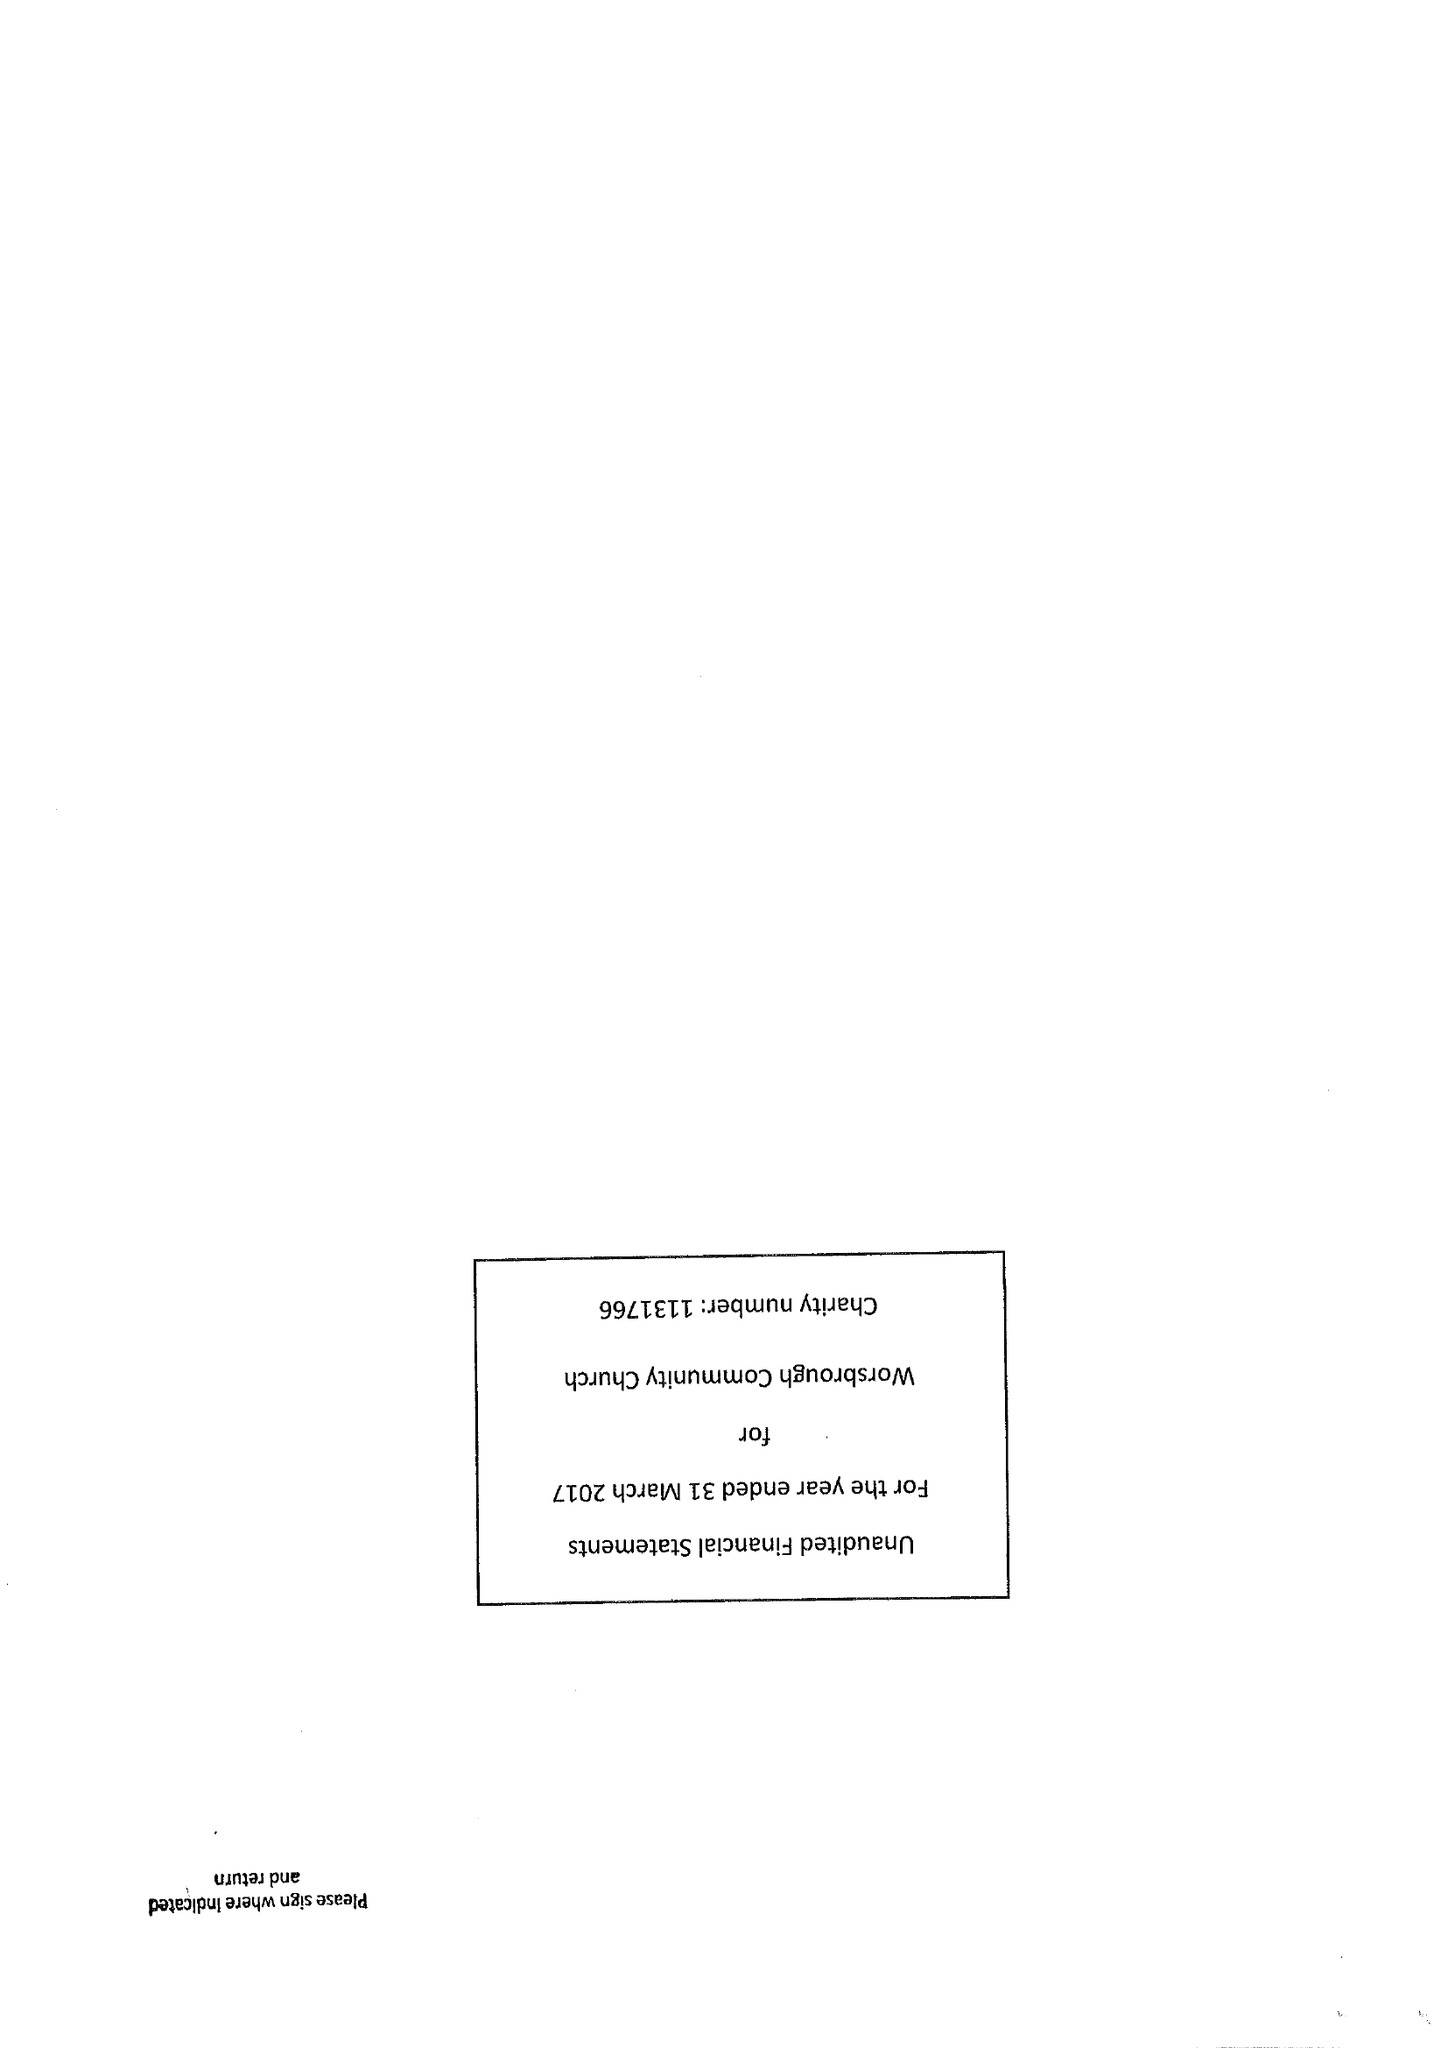What is the value for the charity_name?
Answer the question using a single word or phrase. Worsbrough Community Church 